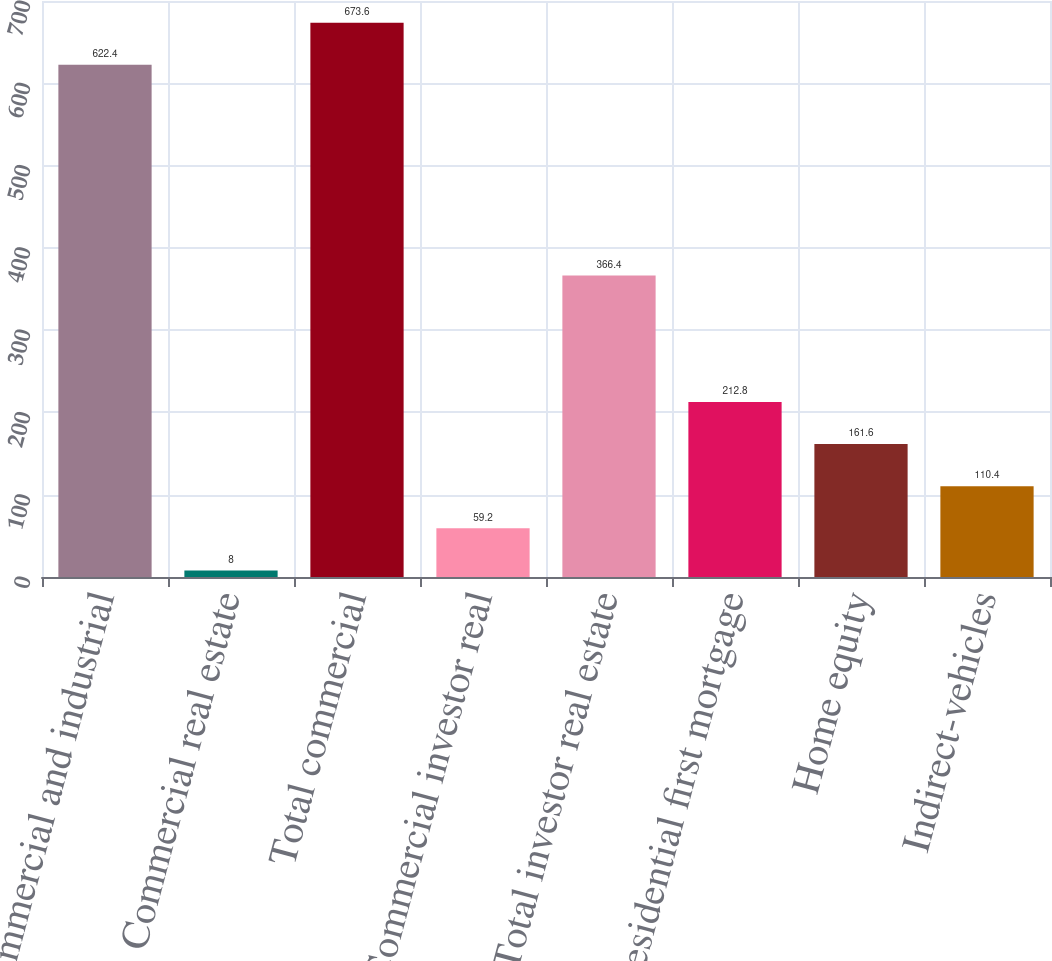<chart> <loc_0><loc_0><loc_500><loc_500><bar_chart><fcel>Commercial and industrial<fcel>Commercial real estate<fcel>Total commercial<fcel>Commercial investor real<fcel>Total investor real estate<fcel>Residential first mortgage<fcel>Home equity<fcel>Indirect-vehicles<nl><fcel>622.4<fcel>8<fcel>673.6<fcel>59.2<fcel>366.4<fcel>212.8<fcel>161.6<fcel>110.4<nl></chart> 